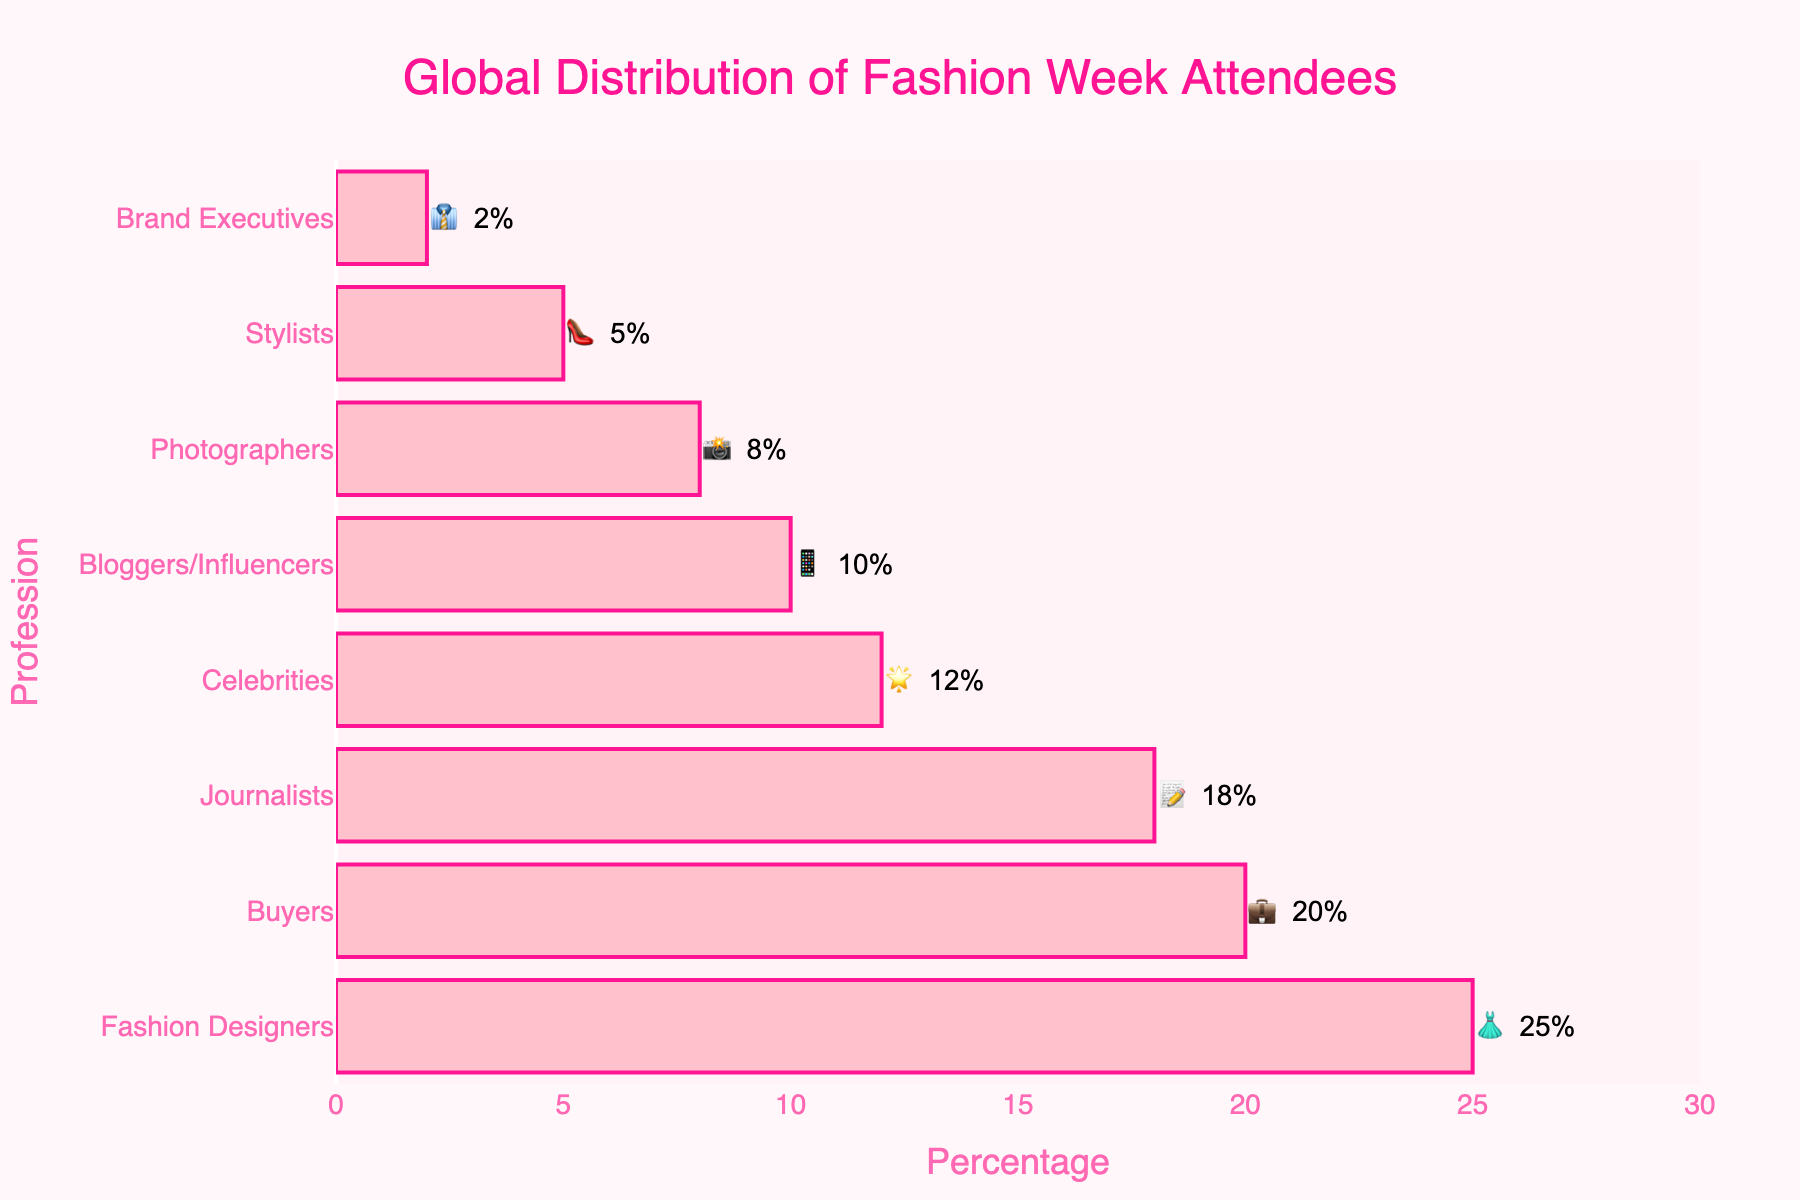what is the title of the figure? The title is usually located at the top of a chart. By reading this area, you can determine that the title of the chart is "Global Distribution of Fashion Week Attendees".
Answer: Global Distribution of Fashion Week Attendees How many professions are listed in the chart? To count the professions, you observe the y-axis as it lists each profession. The total count is the number of unique entries here.
Answer: 8 Which profession has the highest percentage of attendees? By examining the length of the bars, the longest bar indicates the highest percentage. "Fashion Designers" has the longest bar.
Answer: Fashion Designers Which profession has the lowest percentage of attendees? The shortest bar denotes the lowest percentage. Here, "Brand Executives" has the shortest bar.
Answer: Brand Executives What is the combined percentage of celebrities and bloggers/influencers? Add the percentage values for Celebrities (12%) and Bloggers/Influencers (10%).
Answer: 22% What is the difference in percentage between fashion designers and buyers? Subtract the percentage of Buyers (20%) from Fashion Designers (25%) to find the difference.
Answer: 5% If "Photographers" and "Stylists" percentages are combined, do they exceed the percentage of "Journalists"? Sum the percentages of Photographers (8%) and Stylists (5%), then compare this result to the percentage of Journalists (18%).
Answer: No Which two professions collectively make up 50% of the attendees? Identify the two largest percentages that sum up to 50%. Fashion Designers (25%) and Buyers (20%) do not quite reach it. Adding Journalists (18%) exceeds it. Therefore, no exact match.
Answer: None What color scheme is used for the bars? Look at the color of the bars and the border to see shades of pink are used, with the bars in a light pink and a darker pink for the border.
Answer: Shades of pink 